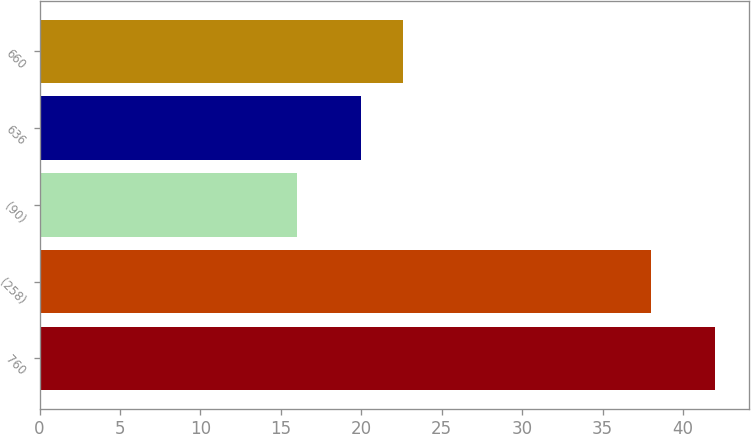Convert chart to OTSL. <chart><loc_0><loc_0><loc_500><loc_500><bar_chart><fcel>760<fcel>(258)<fcel>(90)<fcel>636<fcel>660<nl><fcel>42<fcel>38<fcel>16<fcel>20<fcel>22.6<nl></chart> 